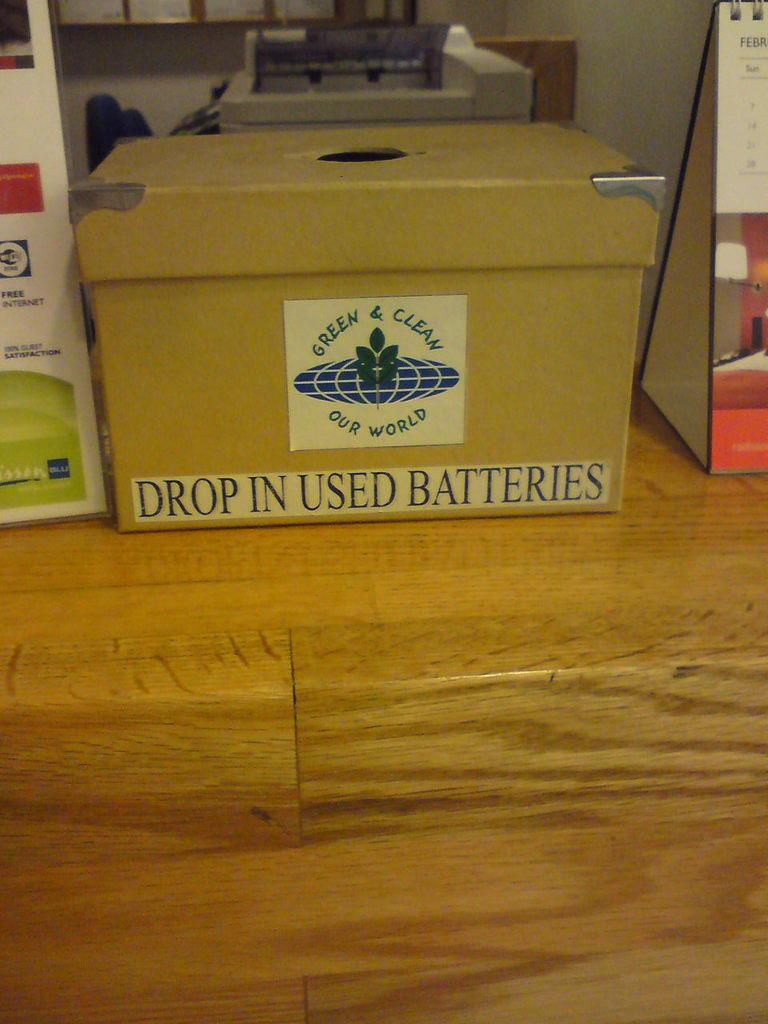<image>
Render a clear and concise summary of the photo. a brown box with the word drop on it 